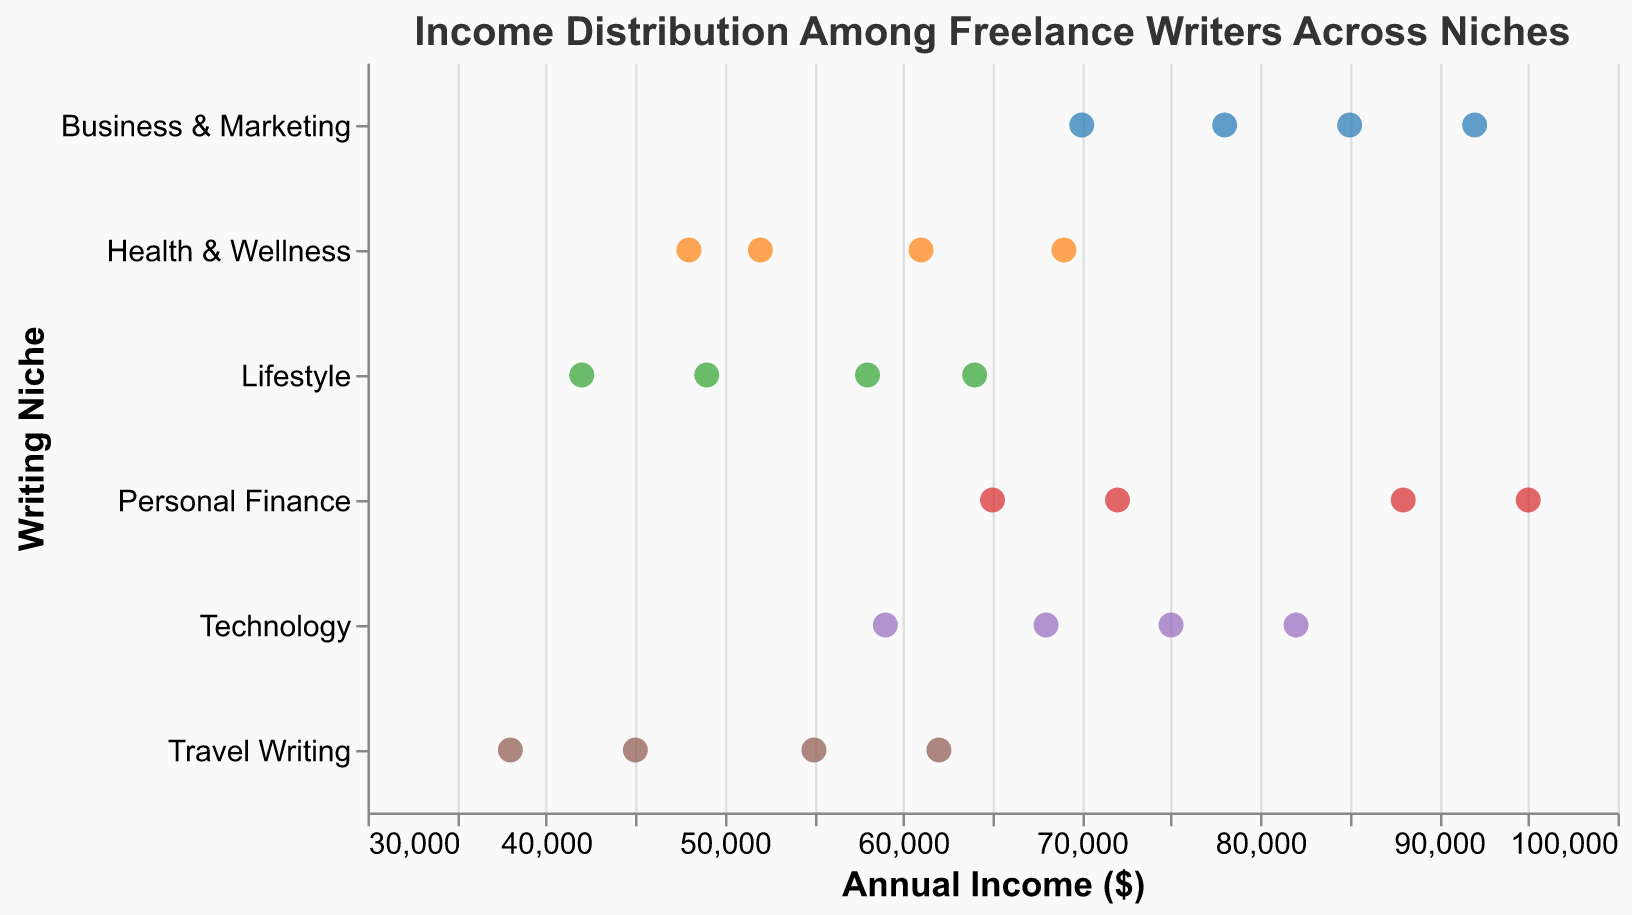How many data points are shown for the "Technology" niche? Count the number of points aligned with the "Technology" label on the y-axis. There are four data points visible.
Answer: 4 What is the title of the plot? The title is displayed at the top of the plot in bold font. It reads "Income Distribution Among Freelance Writers Across Niches".
Answer: Income Distribution Among Freelance Writers Across Niches Which niche has the highest income value displayed, and what is that value? Among the visible points, locate the one with the highest x-axis (Annual Income). The highest value is in the "Personal Finance" niche with an income of $95,000.
Answer: Personal Finance, $95,000 What's the average annual income for the "Travel Writing" niche? There are four data points for Travel Writing: 45000, 62000, 38000, and 55000. Sum them: 200000. Divide by 4 to get the average: 50000.
Answer: $50,000 Compare the lowest income values for "Lifestyle" and "Health & Wellness" niches. Which is lower, and by how much? Identify the lowest values in these niches: $42,000 for Lifestyle and $48,000 for Health & Wellness. Subtract the lower from the higher value: 48000 - 42000 = 6000.
Answer: Lifestyle is lower by $6,000 Which writing niche shows the greatest range in annual incomes from the data points provided? For each niche, identify the minimum and maximum points. Calculate the range by subtracting the minimum from the maximum. The "Personal Finance" niche has the greatest range with incomes from $65,000 to $95,000, giving a range of $30,000.
Answer: Personal Finance If you were to recommend a niche based on the highest median income, which would it be and what is the median? Order the incomes within each niche and find their median. For instance, "Business & Marketing" has incomes: 70000, 78000, 85000, 92000. The median is 81500 (Average of the middle two values: (78000 + 85000) / 2).
Answer: Business & Marketing, $81,500 Are any data points exactly $60,000? If so, identify the niche(s). Scan the x-axis for points located at $60,000. No data points are exactly at this level.
Answer: No What's the combined income of the "Personal Finance" niche? Add the incomes in the "Personal Finance": 72000 + 88000 + 65000 + 95000 = 320000.
Answer: $320,000 Are the income distributions for "Technology" and "Health & Wellness" overlapping? Compare the ranges of both niches. "Technology" ranges from $59,000 to $82,000 and "Health & Wellness" from $48,000 to $69,000. The overlapping range is from $59,000 to $69,000.
Answer: Yes 